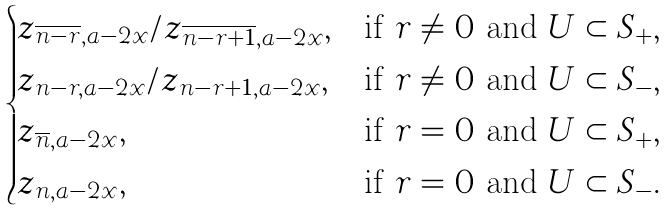Convert formula to latex. <formula><loc_0><loc_0><loc_500><loc_500>\begin{cases} z _ { \overline { n - r } , a - 2 x } / z _ { \overline { n - r + 1 } , a - 2 x } , & \text {if $r\ne 0$ and $U \subset S_{+}$} , \\ z _ { n - r , a - 2 x } / z _ { n - r + 1 , a - 2 x } , & \text {if $r\ne 0$ and $U \subset S_{-}$} , \\ z _ { \overline { n } , a - 2 x } , & \text {if $r=0$ and $U \subset S_{+}$} , \\ z _ { n , a - 2 x } , & \text {if $r=0$ and $U \subset S_{-}$} . \end{cases}</formula> 